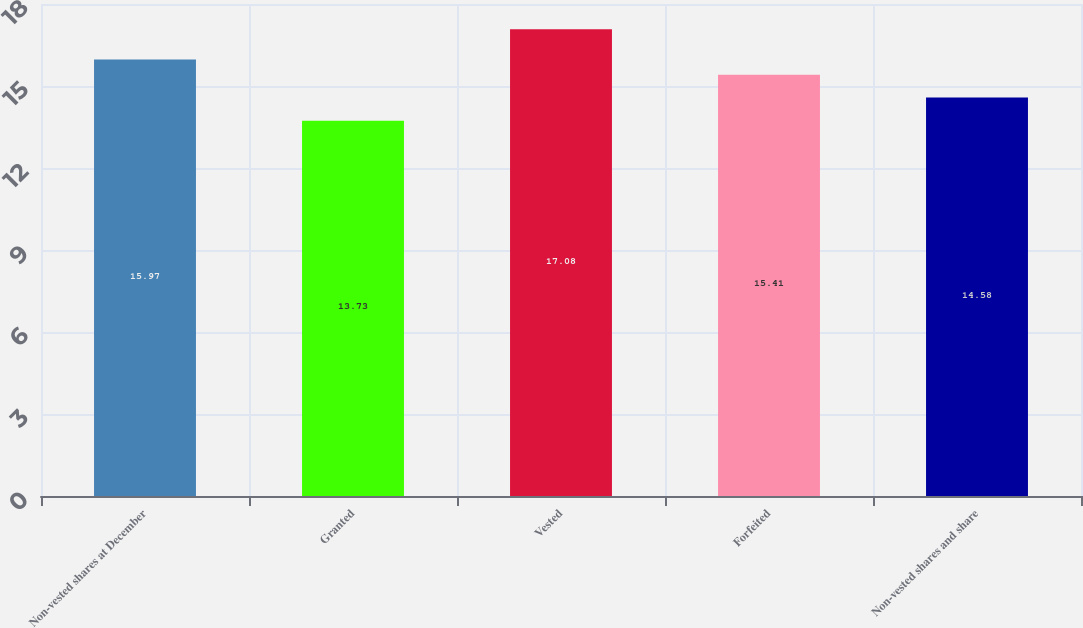Convert chart. <chart><loc_0><loc_0><loc_500><loc_500><bar_chart><fcel>Non-vested shares at December<fcel>Granted<fcel>Vested<fcel>Forfeited<fcel>Non-vested shares and share<nl><fcel>15.97<fcel>13.73<fcel>17.08<fcel>15.41<fcel>14.58<nl></chart> 